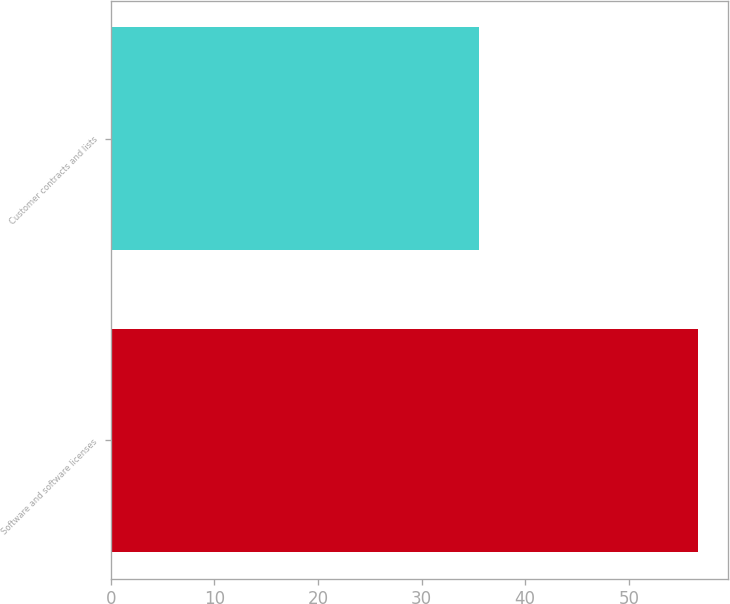Convert chart to OTSL. <chart><loc_0><loc_0><loc_500><loc_500><bar_chart><fcel>Software and software licenses<fcel>Customer contracts and lists<nl><fcel>56.7<fcel>35.5<nl></chart> 